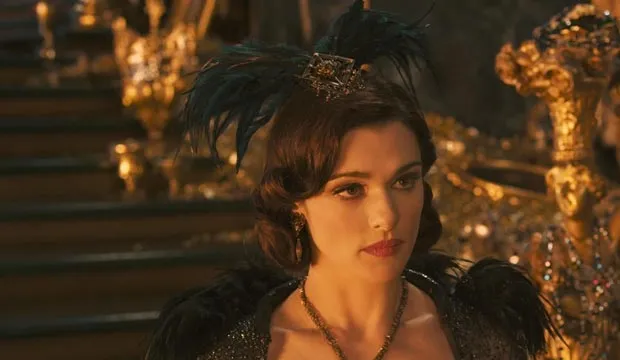What is the significance of Evanora's attire in this scene? Evanora's attire in this scene symbolizes her authority and power. The black and gold colors represent sophistication and wealth, while the feathered headpiece with the gold crown highlights her status and regal demeanor. The elaborate design of her dress signifies her central role within the story and emphasizes the grandeur of the setting. 